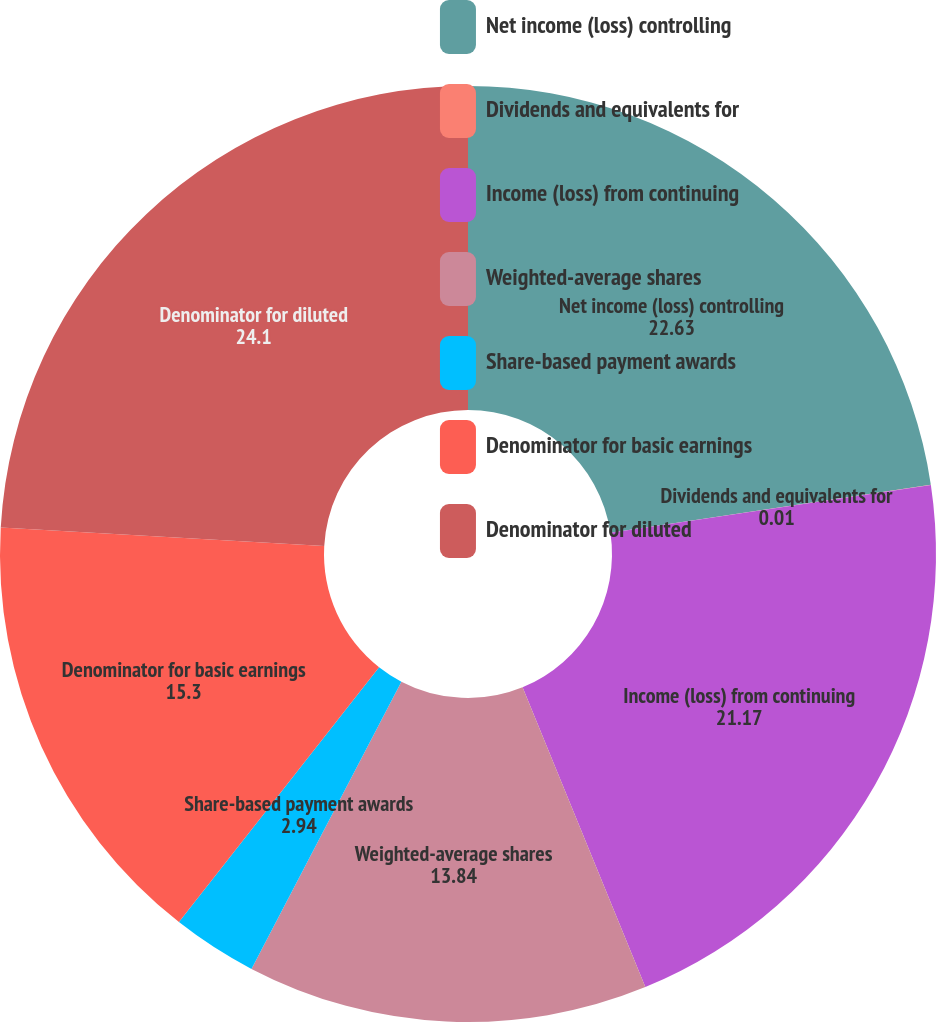<chart> <loc_0><loc_0><loc_500><loc_500><pie_chart><fcel>Net income (loss) controlling<fcel>Dividends and equivalents for<fcel>Income (loss) from continuing<fcel>Weighted-average shares<fcel>Share-based payment awards<fcel>Denominator for basic earnings<fcel>Denominator for diluted<nl><fcel>22.63%<fcel>0.01%<fcel>21.17%<fcel>13.84%<fcel>2.94%<fcel>15.3%<fcel>24.1%<nl></chart> 